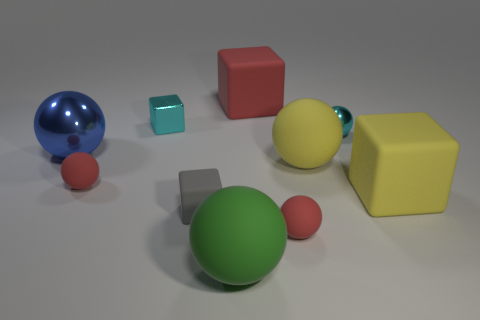Subtract all metal balls. How many balls are left? 4 Subtract all cyan spheres. How many spheres are left? 5 Subtract all cyan spheres. Subtract all gray cylinders. How many spheres are left? 5 Subtract all cubes. How many objects are left? 6 Add 3 cyan objects. How many cyan objects exist? 5 Subtract 1 red cubes. How many objects are left? 9 Subtract all small shiny blocks. Subtract all red matte things. How many objects are left? 6 Add 1 small spheres. How many small spheres are left? 4 